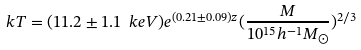Convert formula to latex. <formula><loc_0><loc_0><loc_500><loc_500>k T = ( 1 1 . 2 \pm 1 . 1 \ k e V ) e ^ { ( 0 . 2 1 \pm 0 . 0 9 ) z } ( \frac { M } { 1 0 ^ { 1 5 } h ^ { - 1 } M _ { \odot } } ) ^ { 2 / 3 }</formula> 